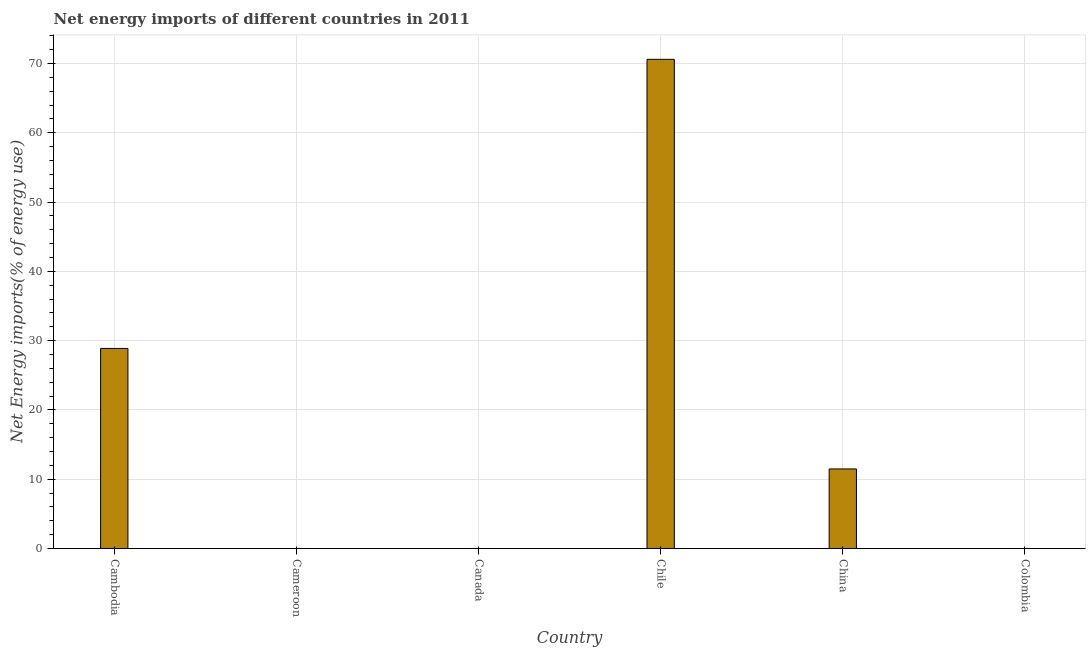What is the title of the graph?
Ensure brevity in your answer.  Net energy imports of different countries in 2011. What is the label or title of the Y-axis?
Provide a succinct answer. Net Energy imports(% of energy use). What is the energy imports in Chile?
Offer a very short reply. 70.6. Across all countries, what is the maximum energy imports?
Your answer should be very brief. 70.6. In which country was the energy imports maximum?
Keep it short and to the point. Chile. What is the sum of the energy imports?
Make the answer very short. 110.96. What is the difference between the energy imports in Cambodia and China?
Keep it short and to the point. 17.39. What is the average energy imports per country?
Keep it short and to the point. 18.49. What is the median energy imports?
Make the answer very short. 5.74. What is the ratio of the energy imports in Cambodia to that in Chile?
Give a very brief answer. 0.41. What is the difference between the highest and the second highest energy imports?
Your response must be concise. 41.73. What is the difference between the highest and the lowest energy imports?
Make the answer very short. 70.6. In how many countries, is the energy imports greater than the average energy imports taken over all countries?
Your response must be concise. 2. How many bars are there?
Your answer should be very brief. 3. How many countries are there in the graph?
Your response must be concise. 6. What is the difference between two consecutive major ticks on the Y-axis?
Make the answer very short. 10. What is the Net Energy imports(% of energy use) in Cambodia?
Make the answer very short. 28.88. What is the Net Energy imports(% of energy use) in Cameroon?
Make the answer very short. 0. What is the Net Energy imports(% of energy use) of Canada?
Provide a short and direct response. 0. What is the Net Energy imports(% of energy use) in Chile?
Make the answer very short. 70.6. What is the Net Energy imports(% of energy use) in China?
Make the answer very short. 11.48. What is the difference between the Net Energy imports(% of energy use) in Cambodia and Chile?
Your response must be concise. -41.72. What is the difference between the Net Energy imports(% of energy use) in Cambodia and China?
Provide a short and direct response. 17.39. What is the difference between the Net Energy imports(% of energy use) in Chile and China?
Provide a short and direct response. 59.12. What is the ratio of the Net Energy imports(% of energy use) in Cambodia to that in Chile?
Your answer should be very brief. 0.41. What is the ratio of the Net Energy imports(% of energy use) in Cambodia to that in China?
Your response must be concise. 2.52. What is the ratio of the Net Energy imports(% of energy use) in Chile to that in China?
Keep it short and to the point. 6.15. 